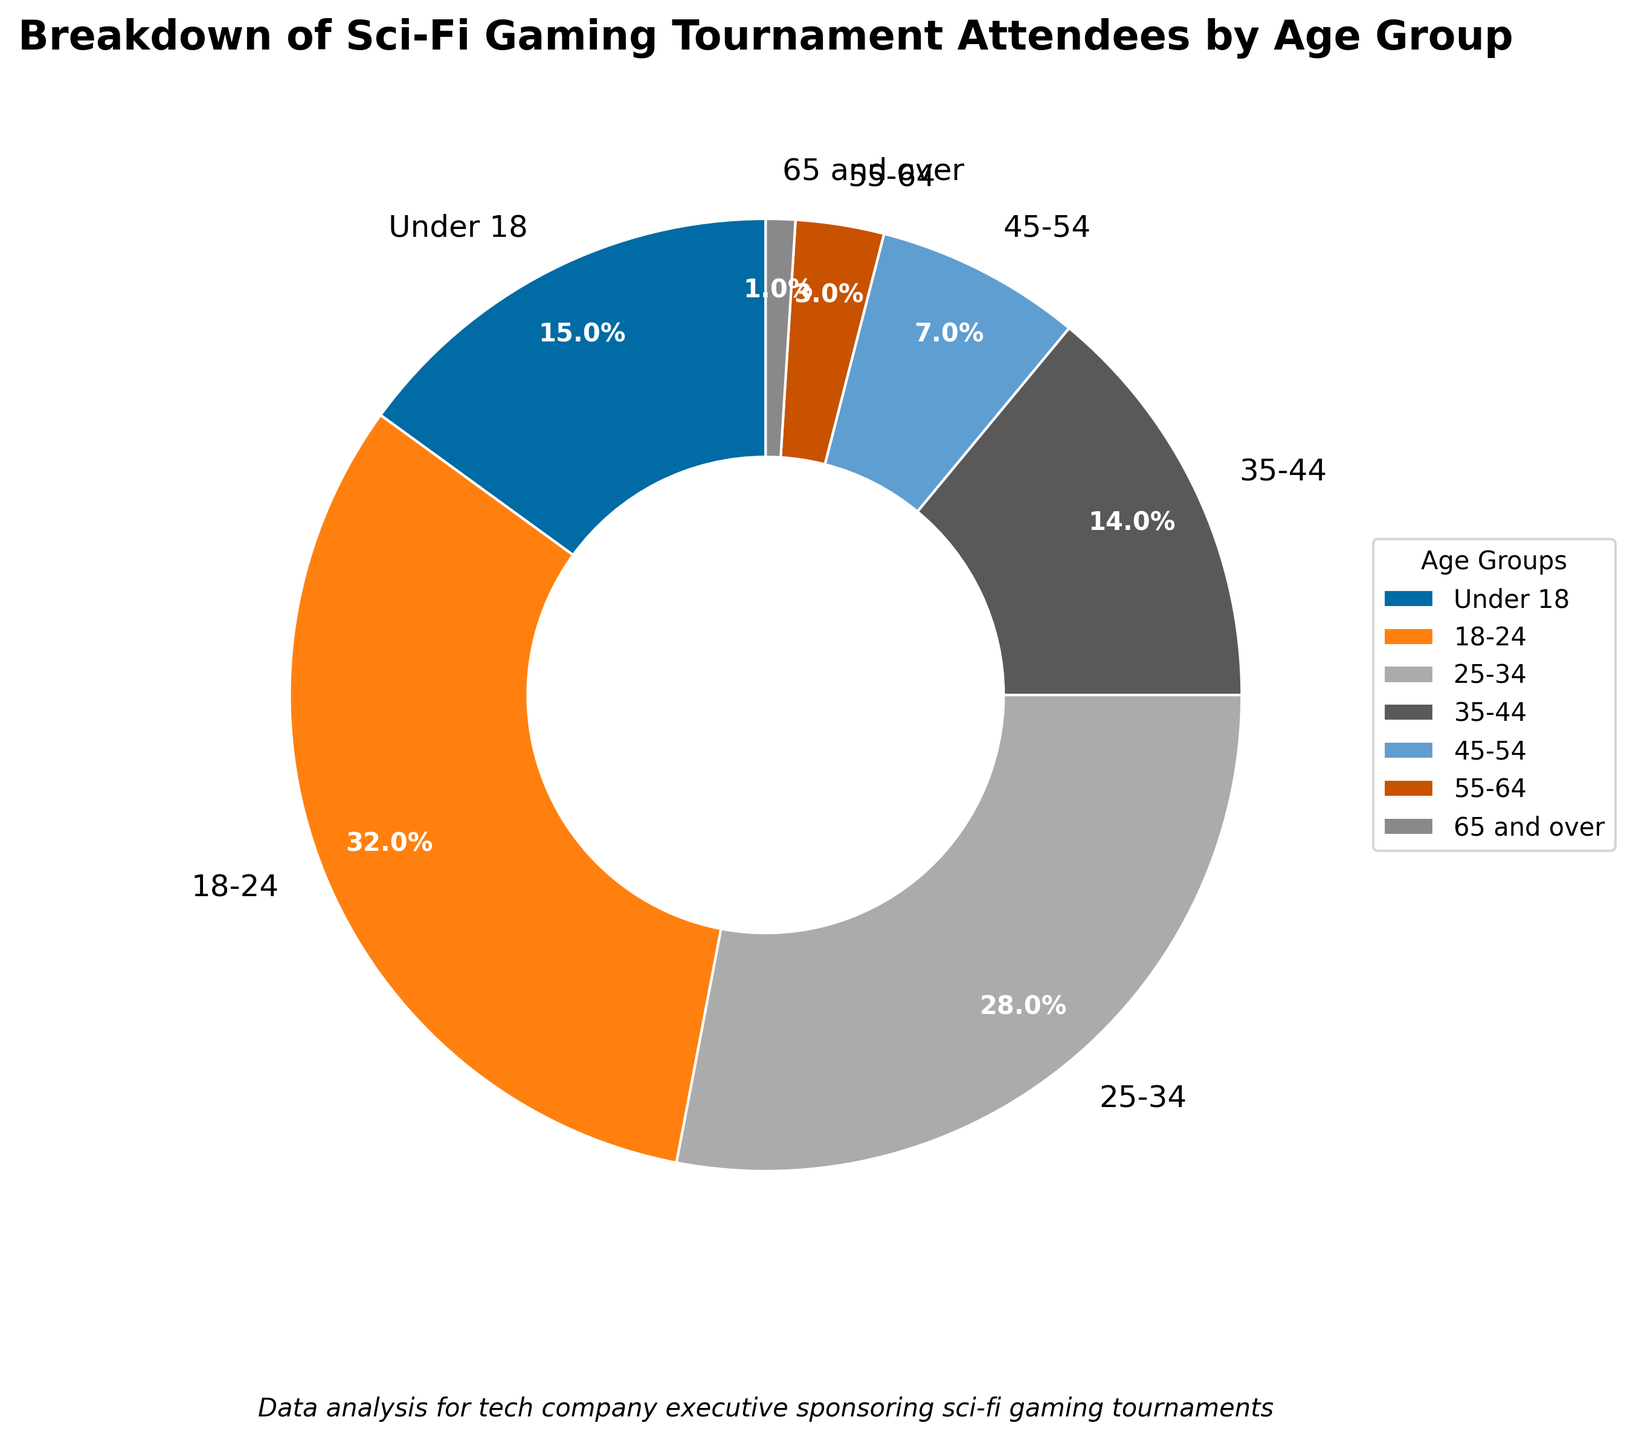What's the age group with the highest percentage of attendees? The pie chart shows the breakdown by age group with percentages. The largest wedge corresponds to the 18-24 age group, which has a 32% share.
Answer: 18-24 Which age groups combined account for more than half of the attendees? To find this, we sum the percentages starting from the highest until the total exceeds 50%. The 18-24 group accounts for 32%, and adding the 25-34 group (28%) gives us 60%, which is more than half.
Answer: 18-24 and 25-34 What percentage of attendees are 35 or older? We sum the percentages of the age groups 35-44, 45-54, 55-64, and 65 and over. That is 14% + 7% + 3% + 1% = 25%.
Answer: 25% Compare the percentage of attendees under 18 to those 55 and over. Which group has a higher percentage, and by how much? The under 18 group has 15%, while the 55-64 and 65 and over groups together account for 4%. 15% - 4% = 11%, so the under 18 group has a higher percentage by 11%.
Answer: Under 18 by 11% What percentage of attendees are under 25? We sum the percentages for the age groups under 18 and 18-24. That is 15% + 32% = 47%.
Answer: 47% Which two age groups have similar percentages of attendees? By observing the pie chart, the 25-34 and 35-44 age groups have values of 28% and 14%, respectively. However, the 35-44 and under 18 age groups have closer values (14% and 15%). 35-44 and under 18 are closer with a difference of 1%.
Answer: 35-44 and under 18 What is the total percentage of attendees in the age groups that each have less than a 10% share? We sum only the percentages of age groups with less than 10%, which are 45-54 (7%), 55-64 (3%), and 65 and over (1%). Thus, 7% + 3% + 1% = 11%.
Answer: 11% How does the percentage of attendees aged 25-34 compare to those aged 35-44? The percentage for the 25-34 group is 28%, while for the 35-44 group it is 14%. The 25-34 group has double the percentage of the 35-44 group.
Answer: 25-34 is double of 35-44 If you consider the middle-aged groups (35-44 and 45-54), what combined percentage do they represent? We sum the percentages of 35-44 and 45-54 age groups. That is 14% + 7% = 21%.
Answer: 21% 